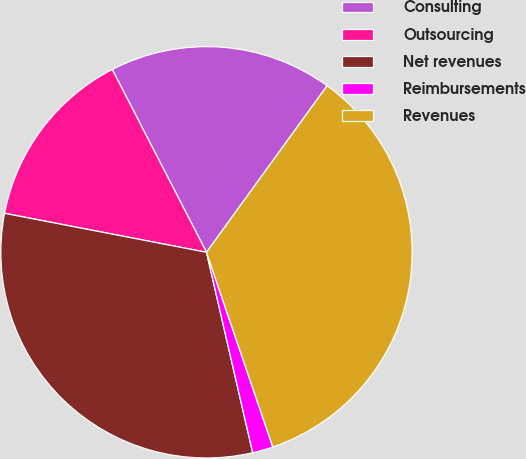Convert chart to OTSL. <chart><loc_0><loc_0><loc_500><loc_500><pie_chart><fcel>Consulting<fcel>Outsourcing<fcel>Net revenues<fcel>Reimbursements<fcel>Revenues<nl><fcel>17.55%<fcel>14.39%<fcel>31.64%<fcel>1.62%<fcel>34.8%<nl></chart> 